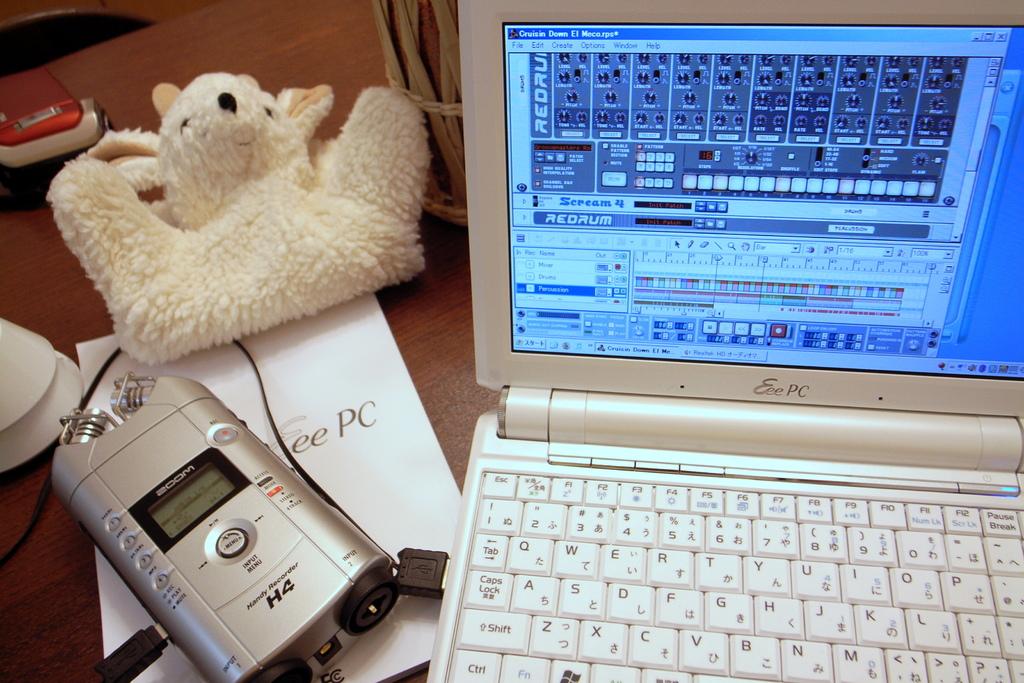What brand is the recorder device?
Your response must be concise. Zoom. 